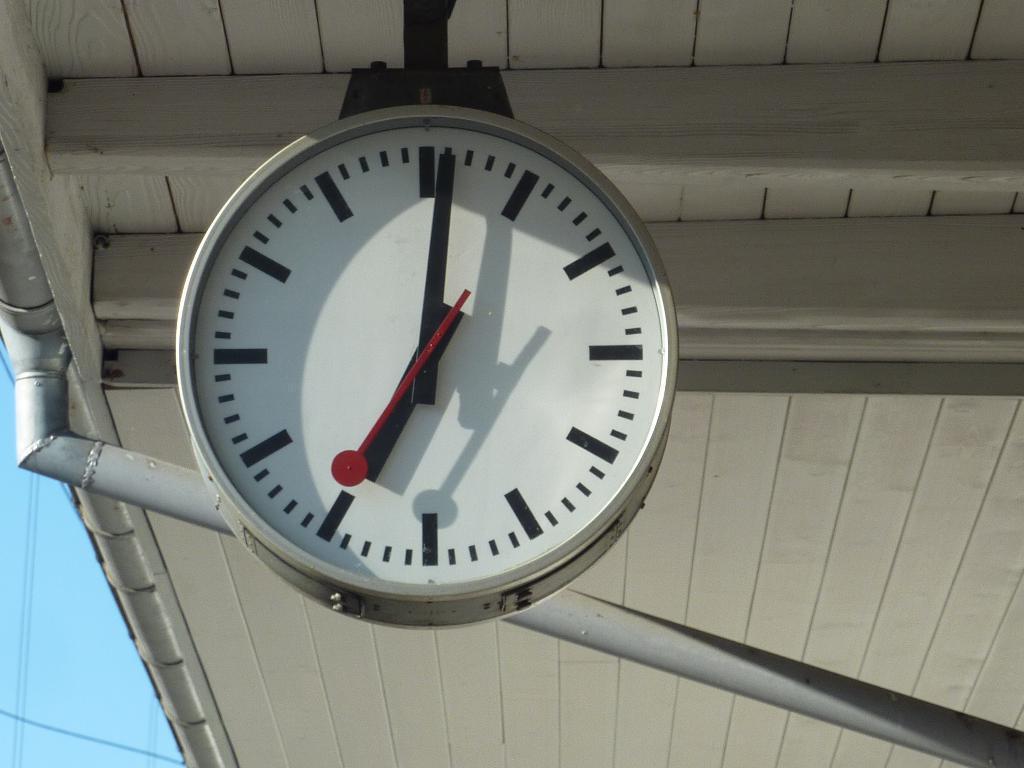Can you describe this image briefly? In this picture there is a clock hanging on the roof in the front and behind the clock there is a pole which is white in colour. 